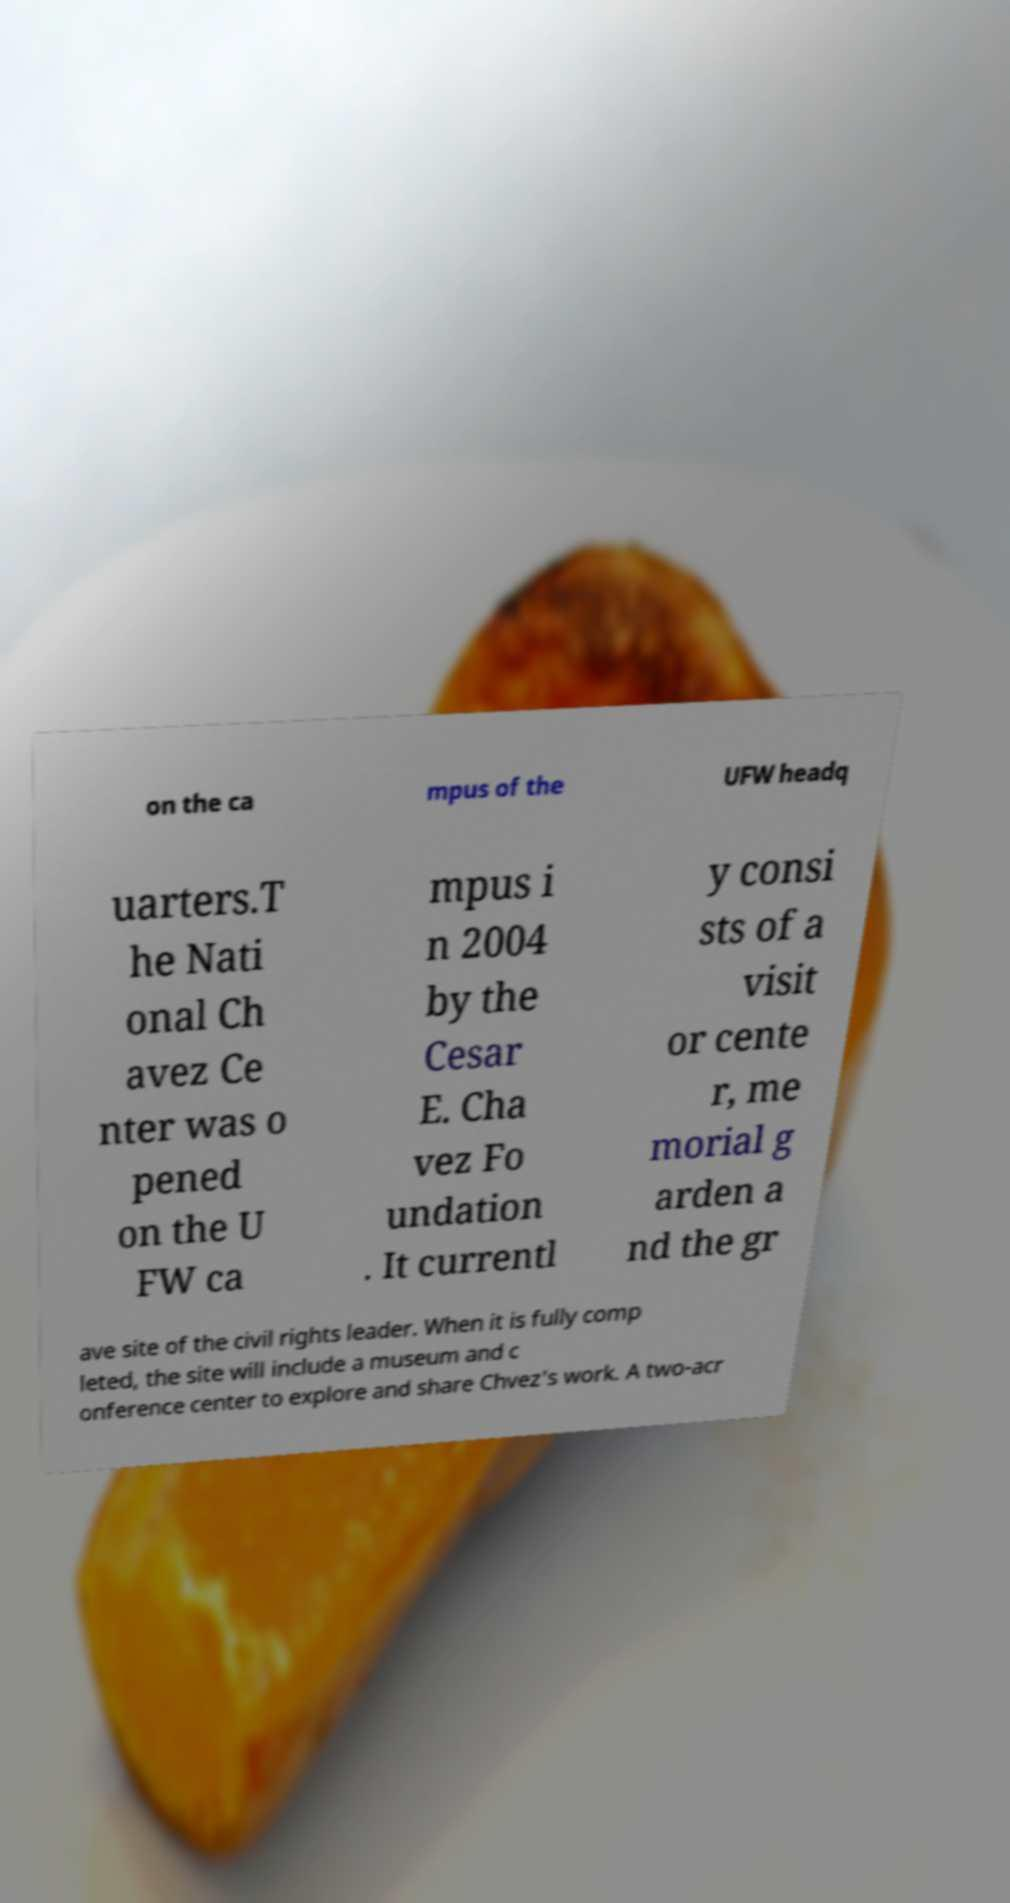There's text embedded in this image that I need extracted. Can you transcribe it verbatim? on the ca mpus of the UFW headq uarters.T he Nati onal Ch avez Ce nter was o pened on the U FW ca mpus i n 2004 by the Cesar E. Cha vez Fo undation . It currentl y consi sts of a visit or cente r, me morial g arden a nd the gr ave site of the civil rights leader. When it is fully comp leted, the site will include a museum and c onference center to explore and share Chvez's work. A two-acr 